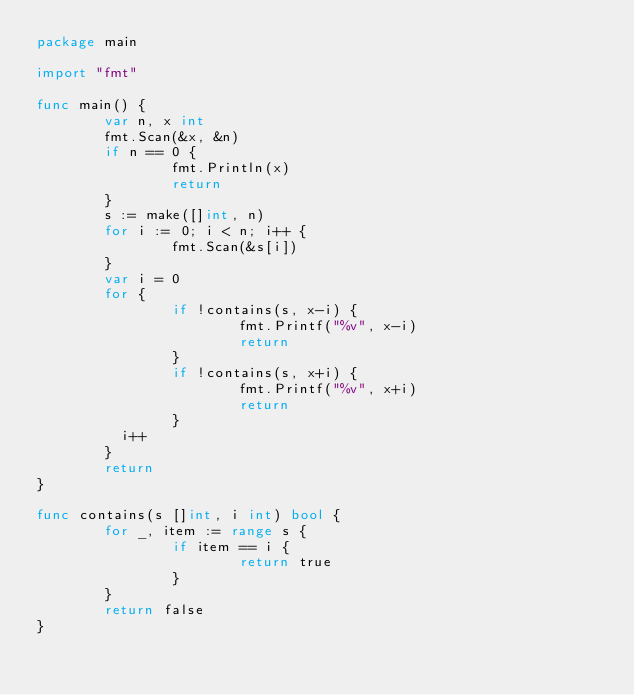<code> <loc_0><loc_0><loc_500><loc_500><_Go_>package main

import "fmt"

func main() {
        var n, x int
        fmt.Scan(&x, &n)
        if n == 0 {
                fmt.Println(x)
                return
        }
        s := make([]int, n)
        for i := 0; i < n; i++ {
                fmt.Scan(&s[i])
        }
        var i = 0
        for {
                if !contains(s, x-i) {
                        fmt.Printf("%v", x-i)
                        return
                }
                if !contains(s, x+i) {
                        fmt.Printf("%v", x+i)
                        return
                }
          i++
        }
        return
}

func contains(s []int, i int) bool {
        for _, item := range s {
                if item == i {
                        return true
                }
        }
        return false
}
</code> 